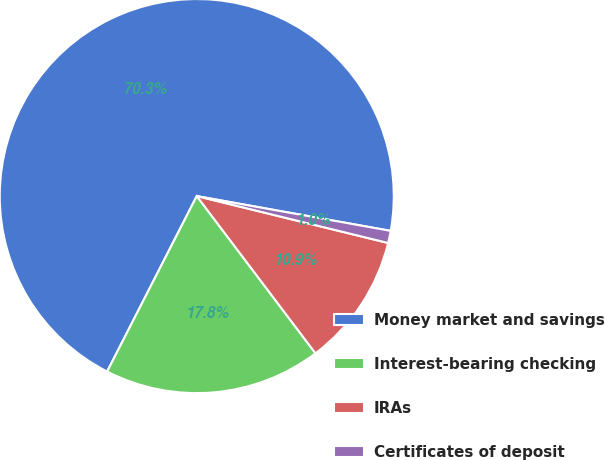Convert chart to OTSL. <chart><loc_0><loc_0><loc_500><loc_500><pie_chart><fcel>Money market and savings<fcel>Interest-bearing checking<fcel>IRAs<fcel>Certificates of deposit<nl><fcel>70.31%<fcel>17.81%<fcel>10.88%<fcel>1.0%<nl></chart> 